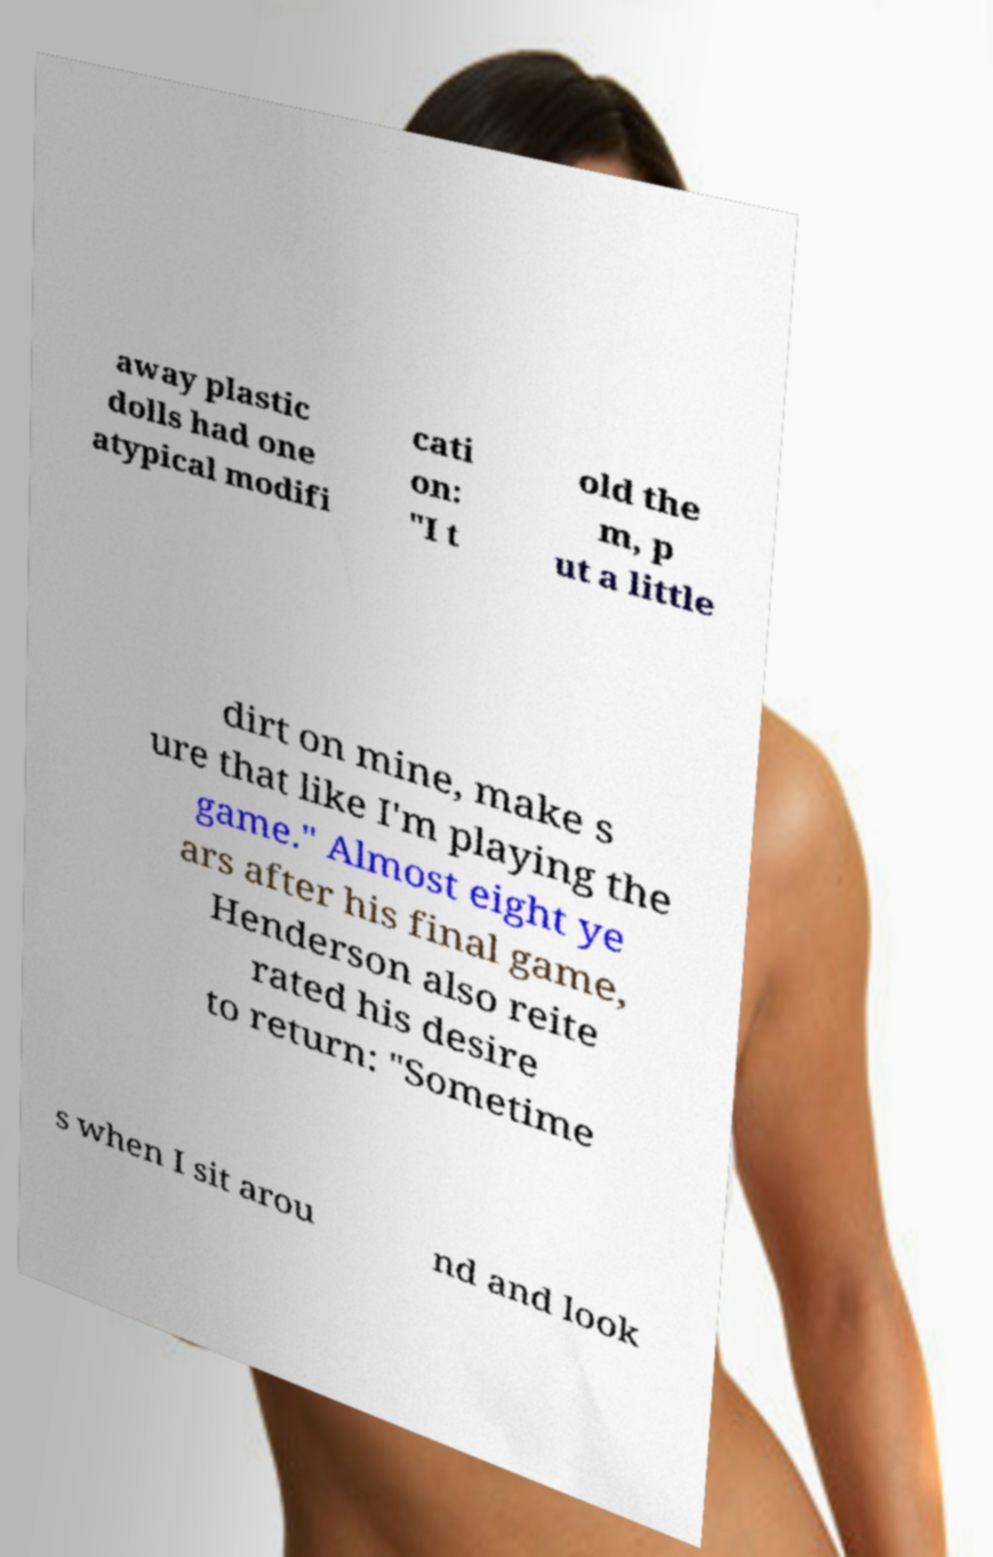Please read and relay the text visible in this image. What does it say? away plastic dolls had one atypical modifi cati on: "I t old the m, p ut a little dirt on mine, make s ure that like I'm playing the game." Almost eight ye ars after his final game, Henderson also reite rated his desire to return: "Sometime s when I sit arou nd and look 